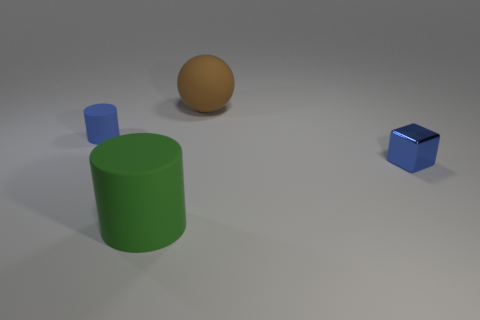Add 1 tiny blue rubber things. How many objects exist? 5 Subtract all balls. How many objects are left? 3 Add 4 small shiny cubes. How many small shiny cubes exist? 5 Subtract 1 blue cylinders. How many objects are left? 3 Subtract all large gray rubber cylinders. Subtract all blue objects. How many objects are left? 2 Add 2 blue shiny blocks. How many blue shiny blocks are left? 3 